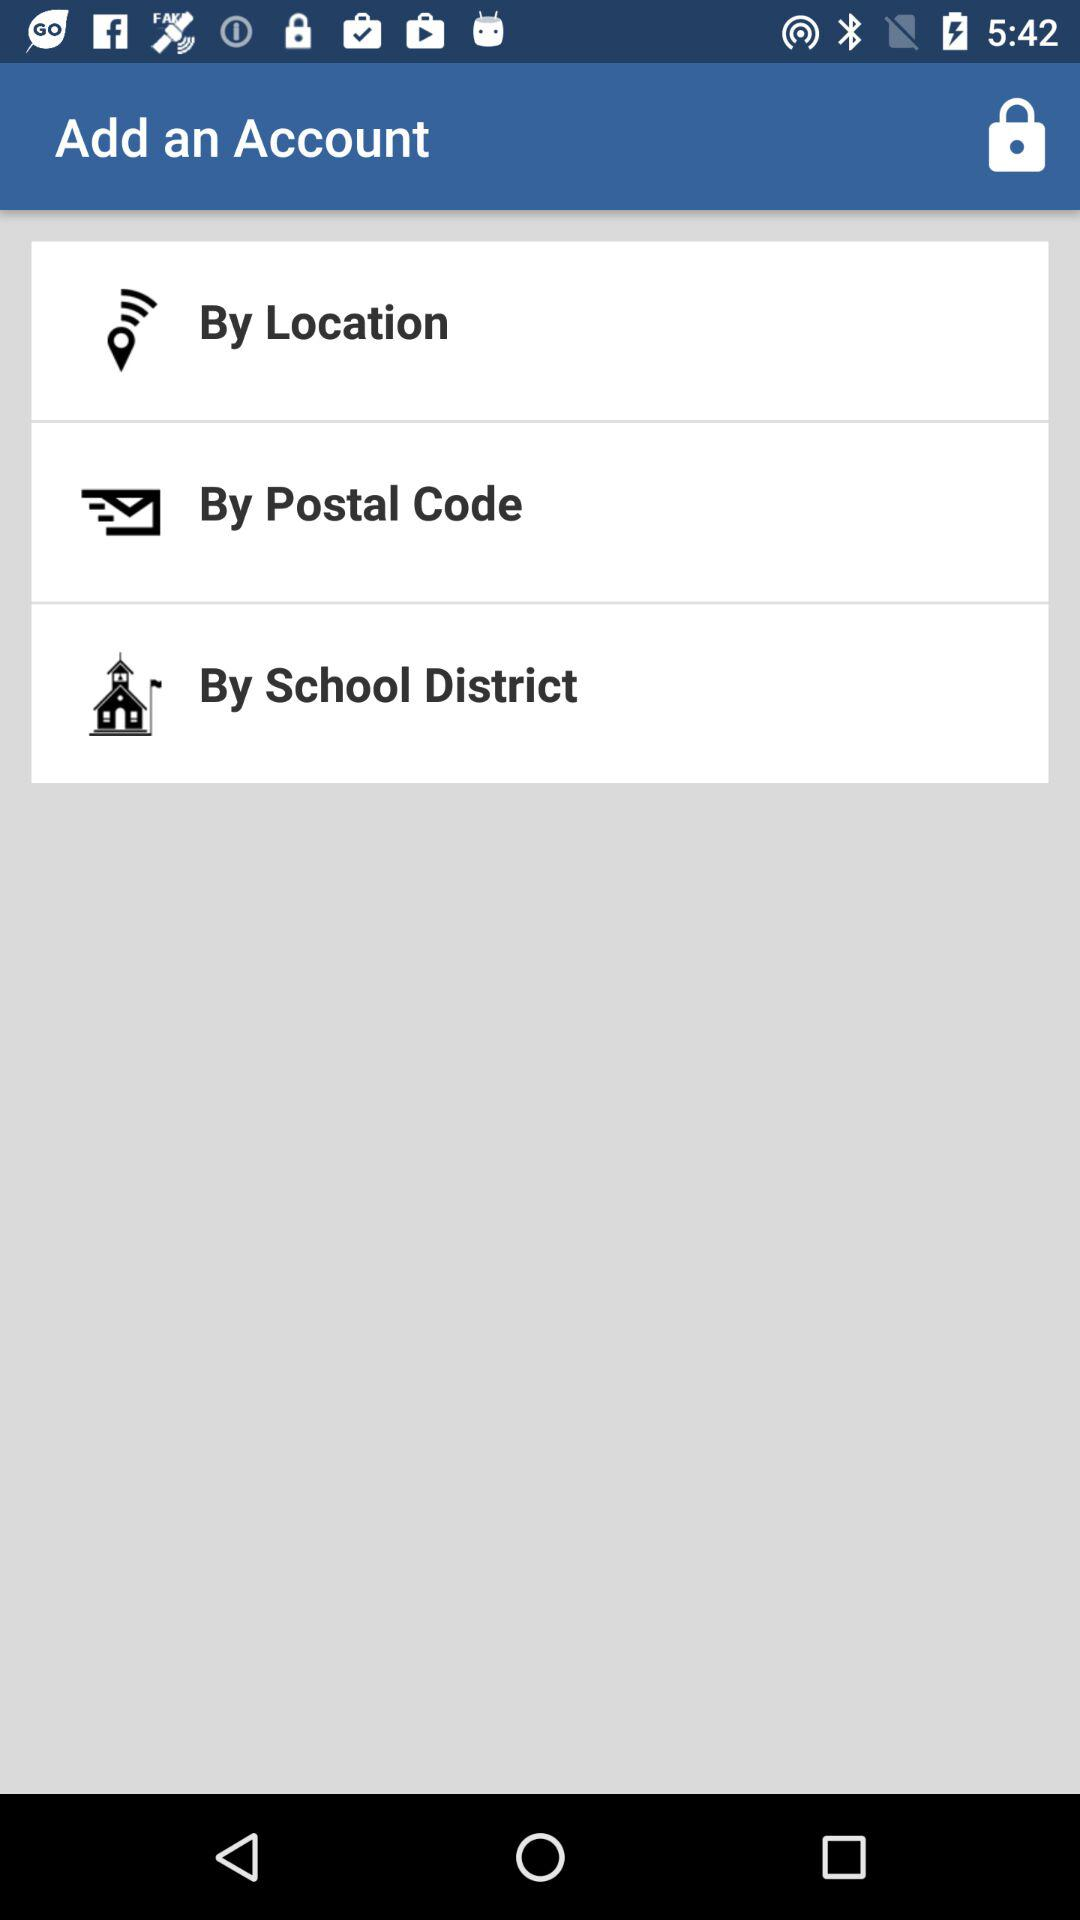Which option is selected to add an account?
When the provided information is insufficient, respond with <no answer>. <no answer> 